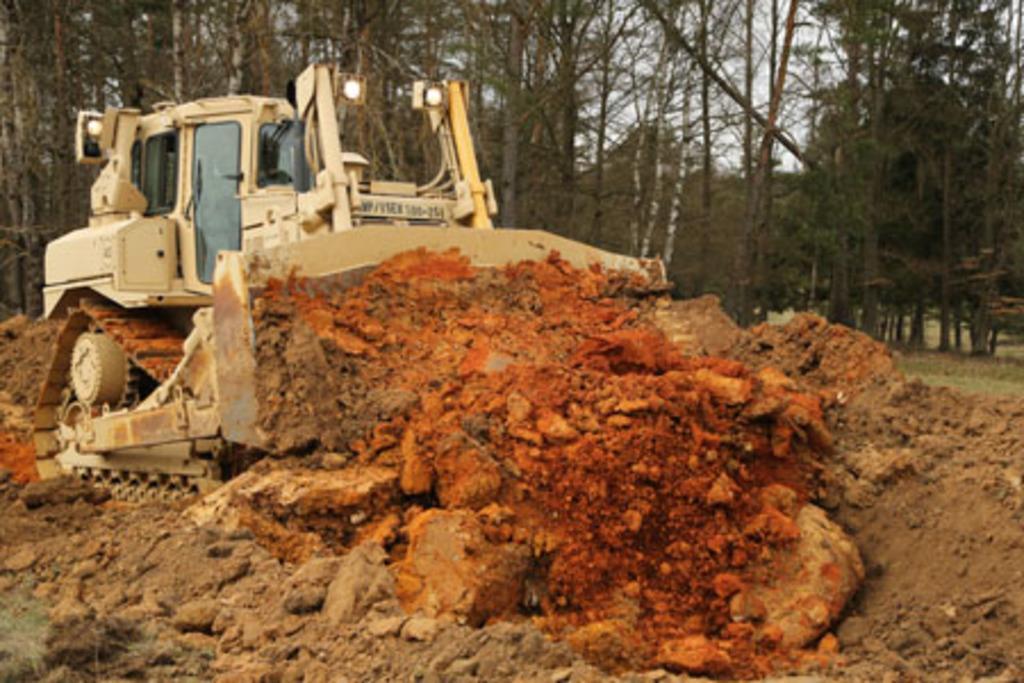Could you give a brief overview of what you see in this image? In the image there is a bulldozer and it is carrying some mud, in the background there are trees. 